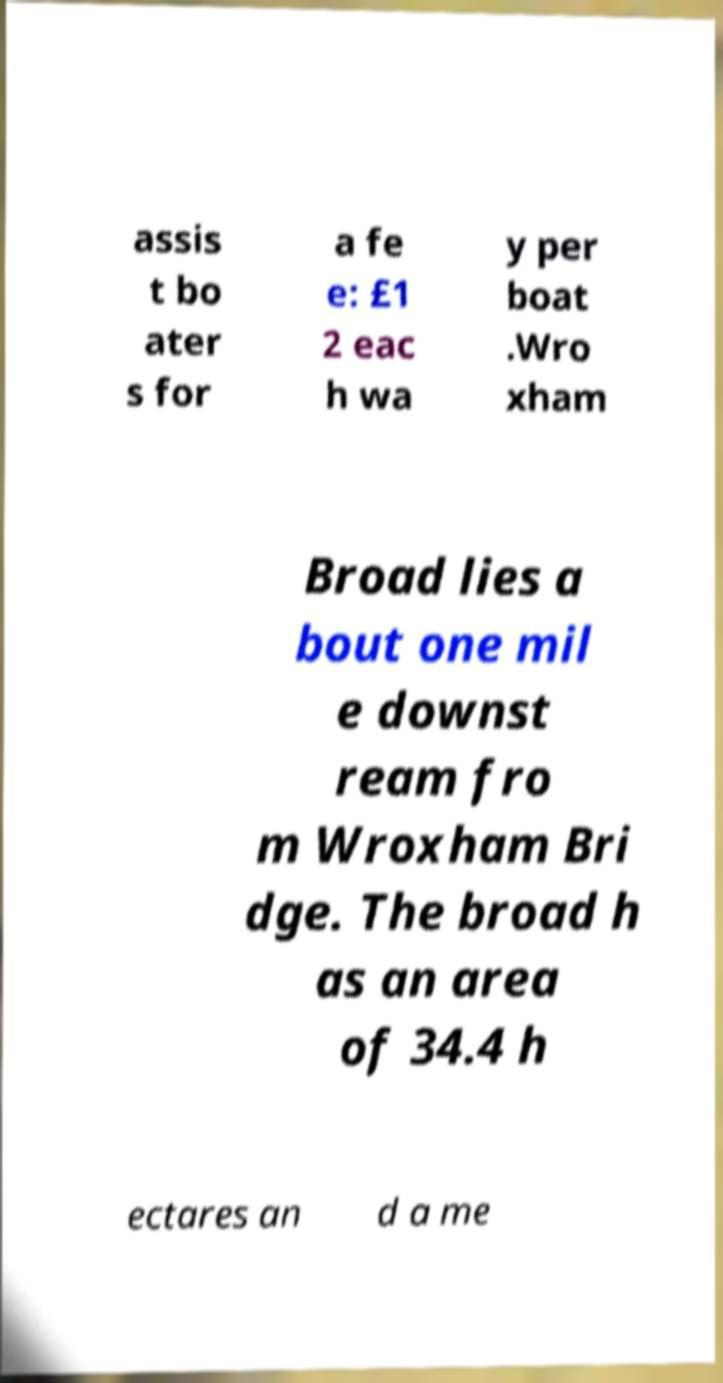For documentation purposes, I need the text within this image transcribed. Could you provide that? assis t bo ater s for a fe e: £1 2 eac h wa y per boat .Wro xham Broad lies a bout one mil e downst ream fro m Wroxham Bri dge. The broad h as an area of 34.4 h ectares an d a me 